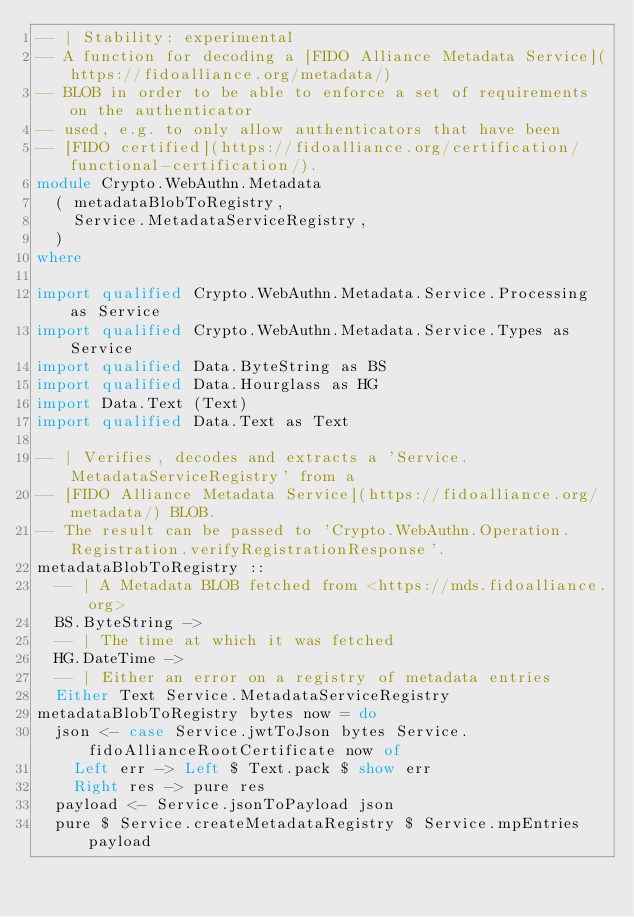Convert code to text. <code><loc_0><loc_0><loc_500><loc_500><_Haskell_>-- | Stability: experimental
-- A function for decoding a [FIDO Alliance Metadata Service](https://fidoalliance.org/metadata/)
-- BLOB in order to be able to enforce a set of requirements on the authenticator
-- used, e.g. to only allow authenticators that have been
-- [FIDO certified](https://fidoalliance.org/certification/functional-certification/).
module Crypto.WebAuthn.Metadata
  ( metadataBlobToRegistry,
    Service.MetadataServiceRegistry,
  )
where

import qualified Crypto.WebAuthn.Metadata.Service.Processing as Service
import qualified Crypto.WebAuthn.Metadata.Service.Types as Service
import qualified Data.ByteString as BS
import qualified Data.Hourglass as HG
import Data.Text (Text)
import qualified Data.Text as Text

-- | Verifies, decodes and extracts a 'Service.MetadataServiceRegistry' from a
-- [FIDO Alliance Metadata Service](https://fidoalliance.org/metadata/) BLOB.
-- The result can be passed to 'Crypto.WebAuthn.Operation.Registration.verifyRegistrationResponse'.
metadataBlobToRegistry ::
  -- | A Metadata BLOB fetched from <https://mds.fidoalliance.org>
  BS.ByteString ->
  -- | The time at which it was fetched
  HG.DateTime ->
  -- | Either an error on a registry of metadata entries
  Either Text Service.MetadataServiceRegistry
metadataBlobToRegistry bytes now = do
  json <- case Service.jwtToJson bytes Service.fidoAllianceRootCertificate now of
    Left err -> Left $ Text.pack $ show err
    Right res -> pure res
  payload <- Service.jsonToPayload json
  pure $ Service.createMetadataRegistry $ Service.mpEntries payload
</code> 